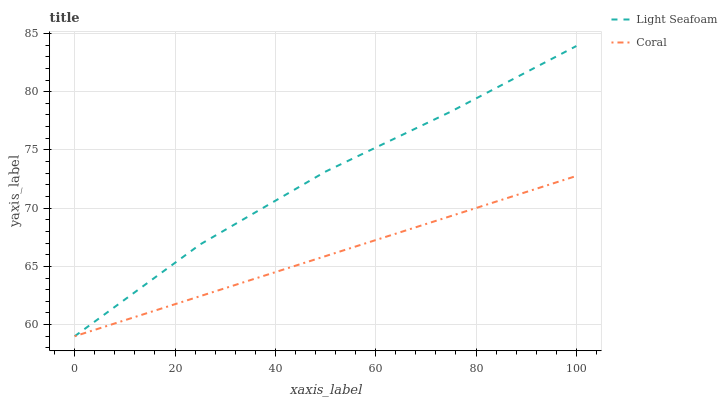Does Coral have the minimum area under the curve?
Answer yes or no. Yes. Does Light Seafoam have the maximum area under the curve?
Answer yes or no. Yes. Does Light Seafoam have the minimum area under the curve?
Answer yes or no. No. Is Coral the smoothest?
Answer yes or no. Yes. Is Light Seafoam the roughest?
Answer yes or no. Yes. Is Light Seafoam the smoothest?
Answer yes or no. No. Does Coral have the lowest value?
Answer yes or no. Yes. Does Light Seafoam have the highest value?
Answer yes or no. Yes. Does Coral intersect Light Seafoam?
Answer yes or no. Yes. Is Coral less than Light Seafoam?
Answer yes or no. No. Is Coral greater than Light Seafoam?
Answer yes or no. No. 